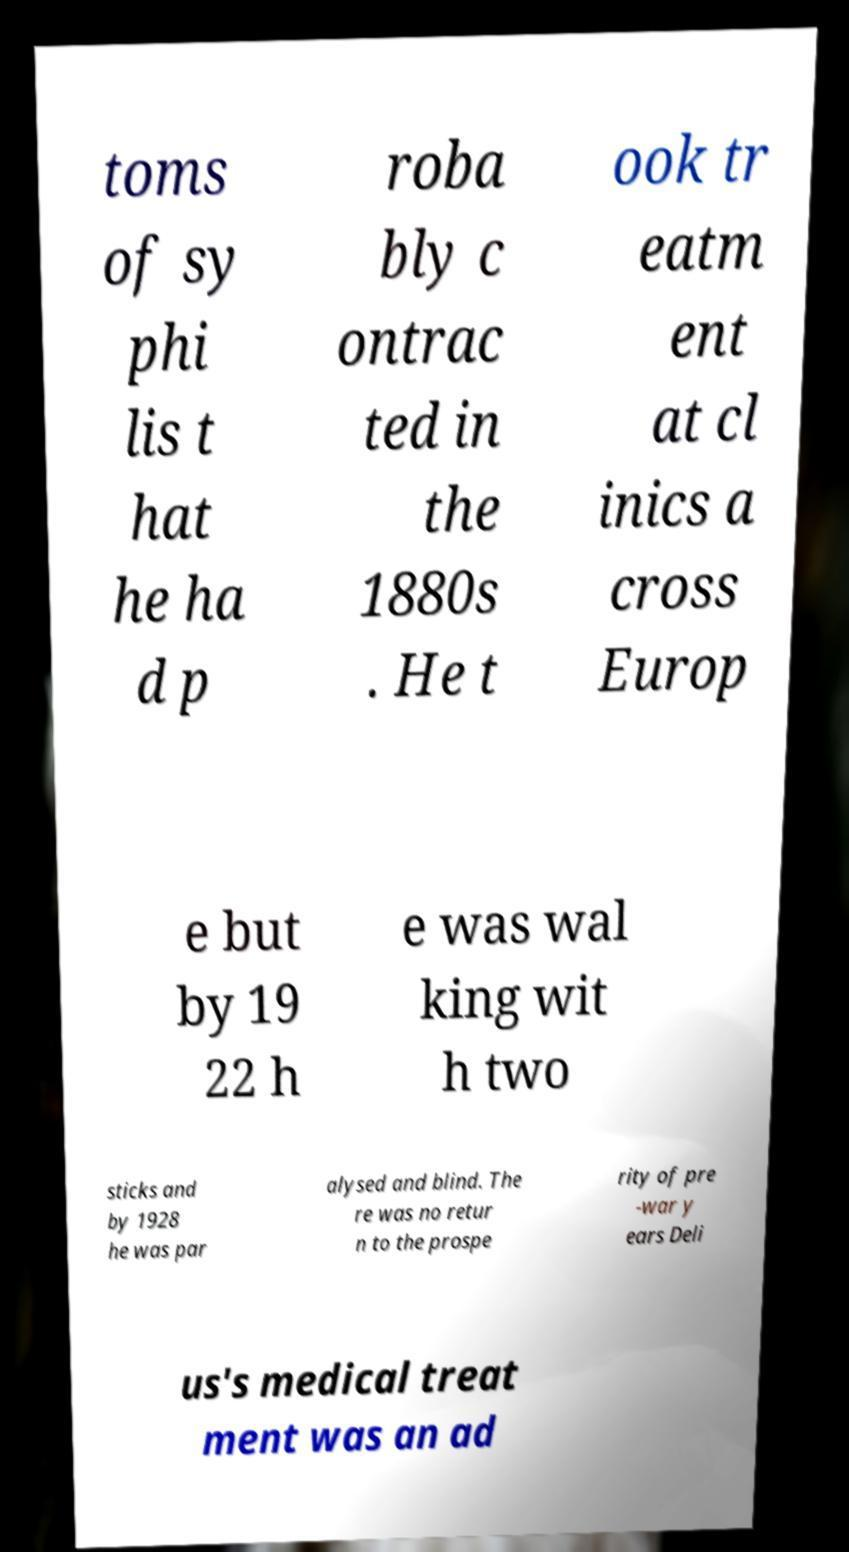I need the written content from this picture converted into text. Can you do that? toms of sy phi lis t hat he ha d p roba bly c ontrac ted in the 1880s . He t ook tr eatm ent at cl inics a cross Europ e but by 19 22 h e was wal king wit h two sticks and by 1928 he was par alysed and blind. The re was no retur n to the prospe rity of pre -war y ears Deli us's medical treat ment was an ad 